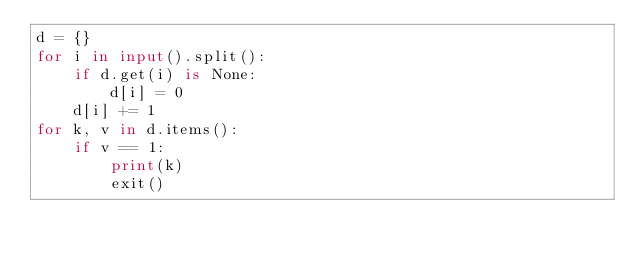Convert code to text. <code><loc_0><loc_0><loc_500><loc_500><_Python_>d = {}
for i in input().split():
    if d.get(i) is None:
        d[i] = 0
    d[i] += 1
for k, v in d.items():
    if v == 1:
        print(k)
        exit()</code> 